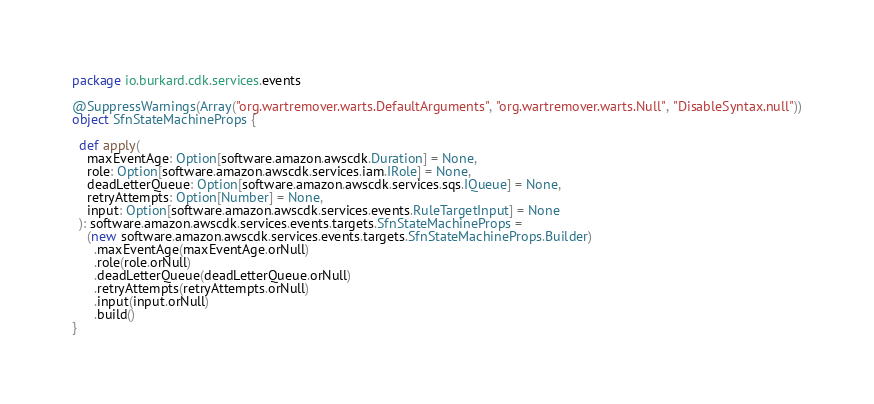Convert code to text. <code><loc_0><loc_0><loc_500><loc_500><_Scala_>package io.burkard.cdk.services.events

@SuppressWarnings(Array("org.wartremover.warts.DefaultArguments", "org.wartremover.warts.Null", "DisableSyntax.null"))
object SfnStateMachineProps {

  def apply(
    maxEventAge: Option[software.amazon.awscdk.Duration] = None,
    role: Option[software.amazon.awscdk.services.iam.IRole] = None,
    deadLetterQueue: Option[software.amazon.awscdk.services.sqs.IQueue] = None,
    retryAttempts: Option[Number] = None,
    input: Option[software.amazon.awscdk.services.events.RuleTargetInput] = None
  ): software.amazon.awscdk.services.events.targets.SfnStateMachineProps =
    (new software.amazon.awscdk.services.events.targets.SfnStateMachineProps.Builder)
      .maxEventAge(maxEventAge.orNull)
      .role(role.orNull)
      .deadLetterQueue(deadLetterQueue.orNull)
      .retryAttempts(retryAttempts.orNull)
      .input(input.orNull)
      .build()
}
</code> 